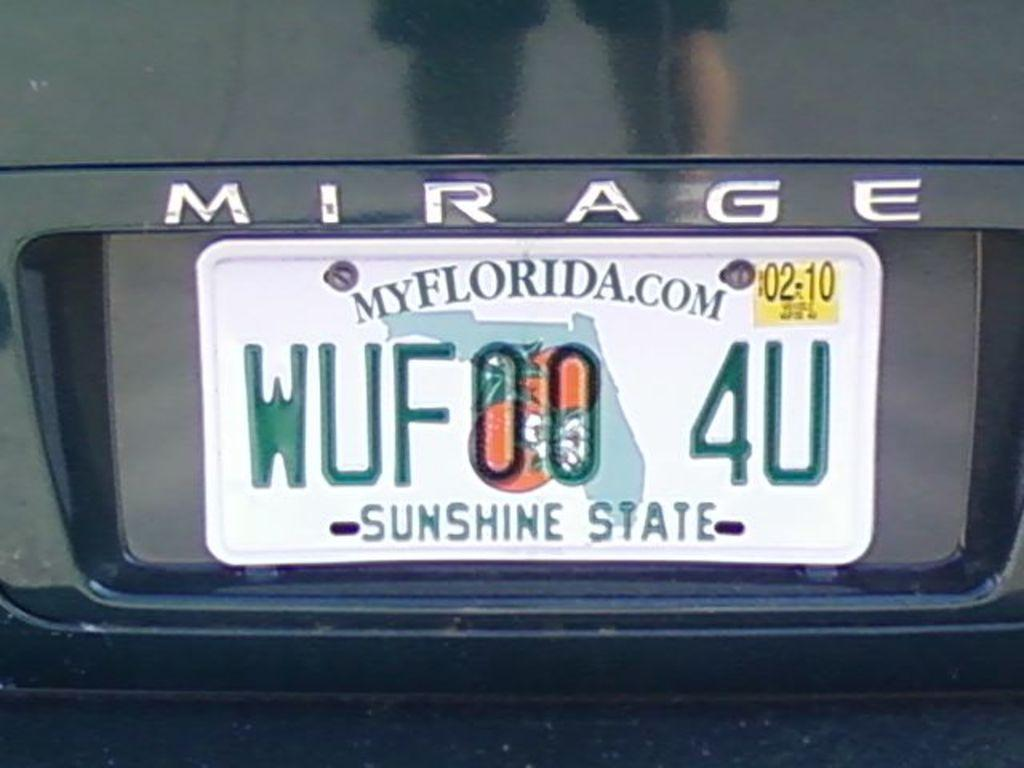Provide a one-sentence caption for the provided image. Florida license on a Mirage is shown up close. 